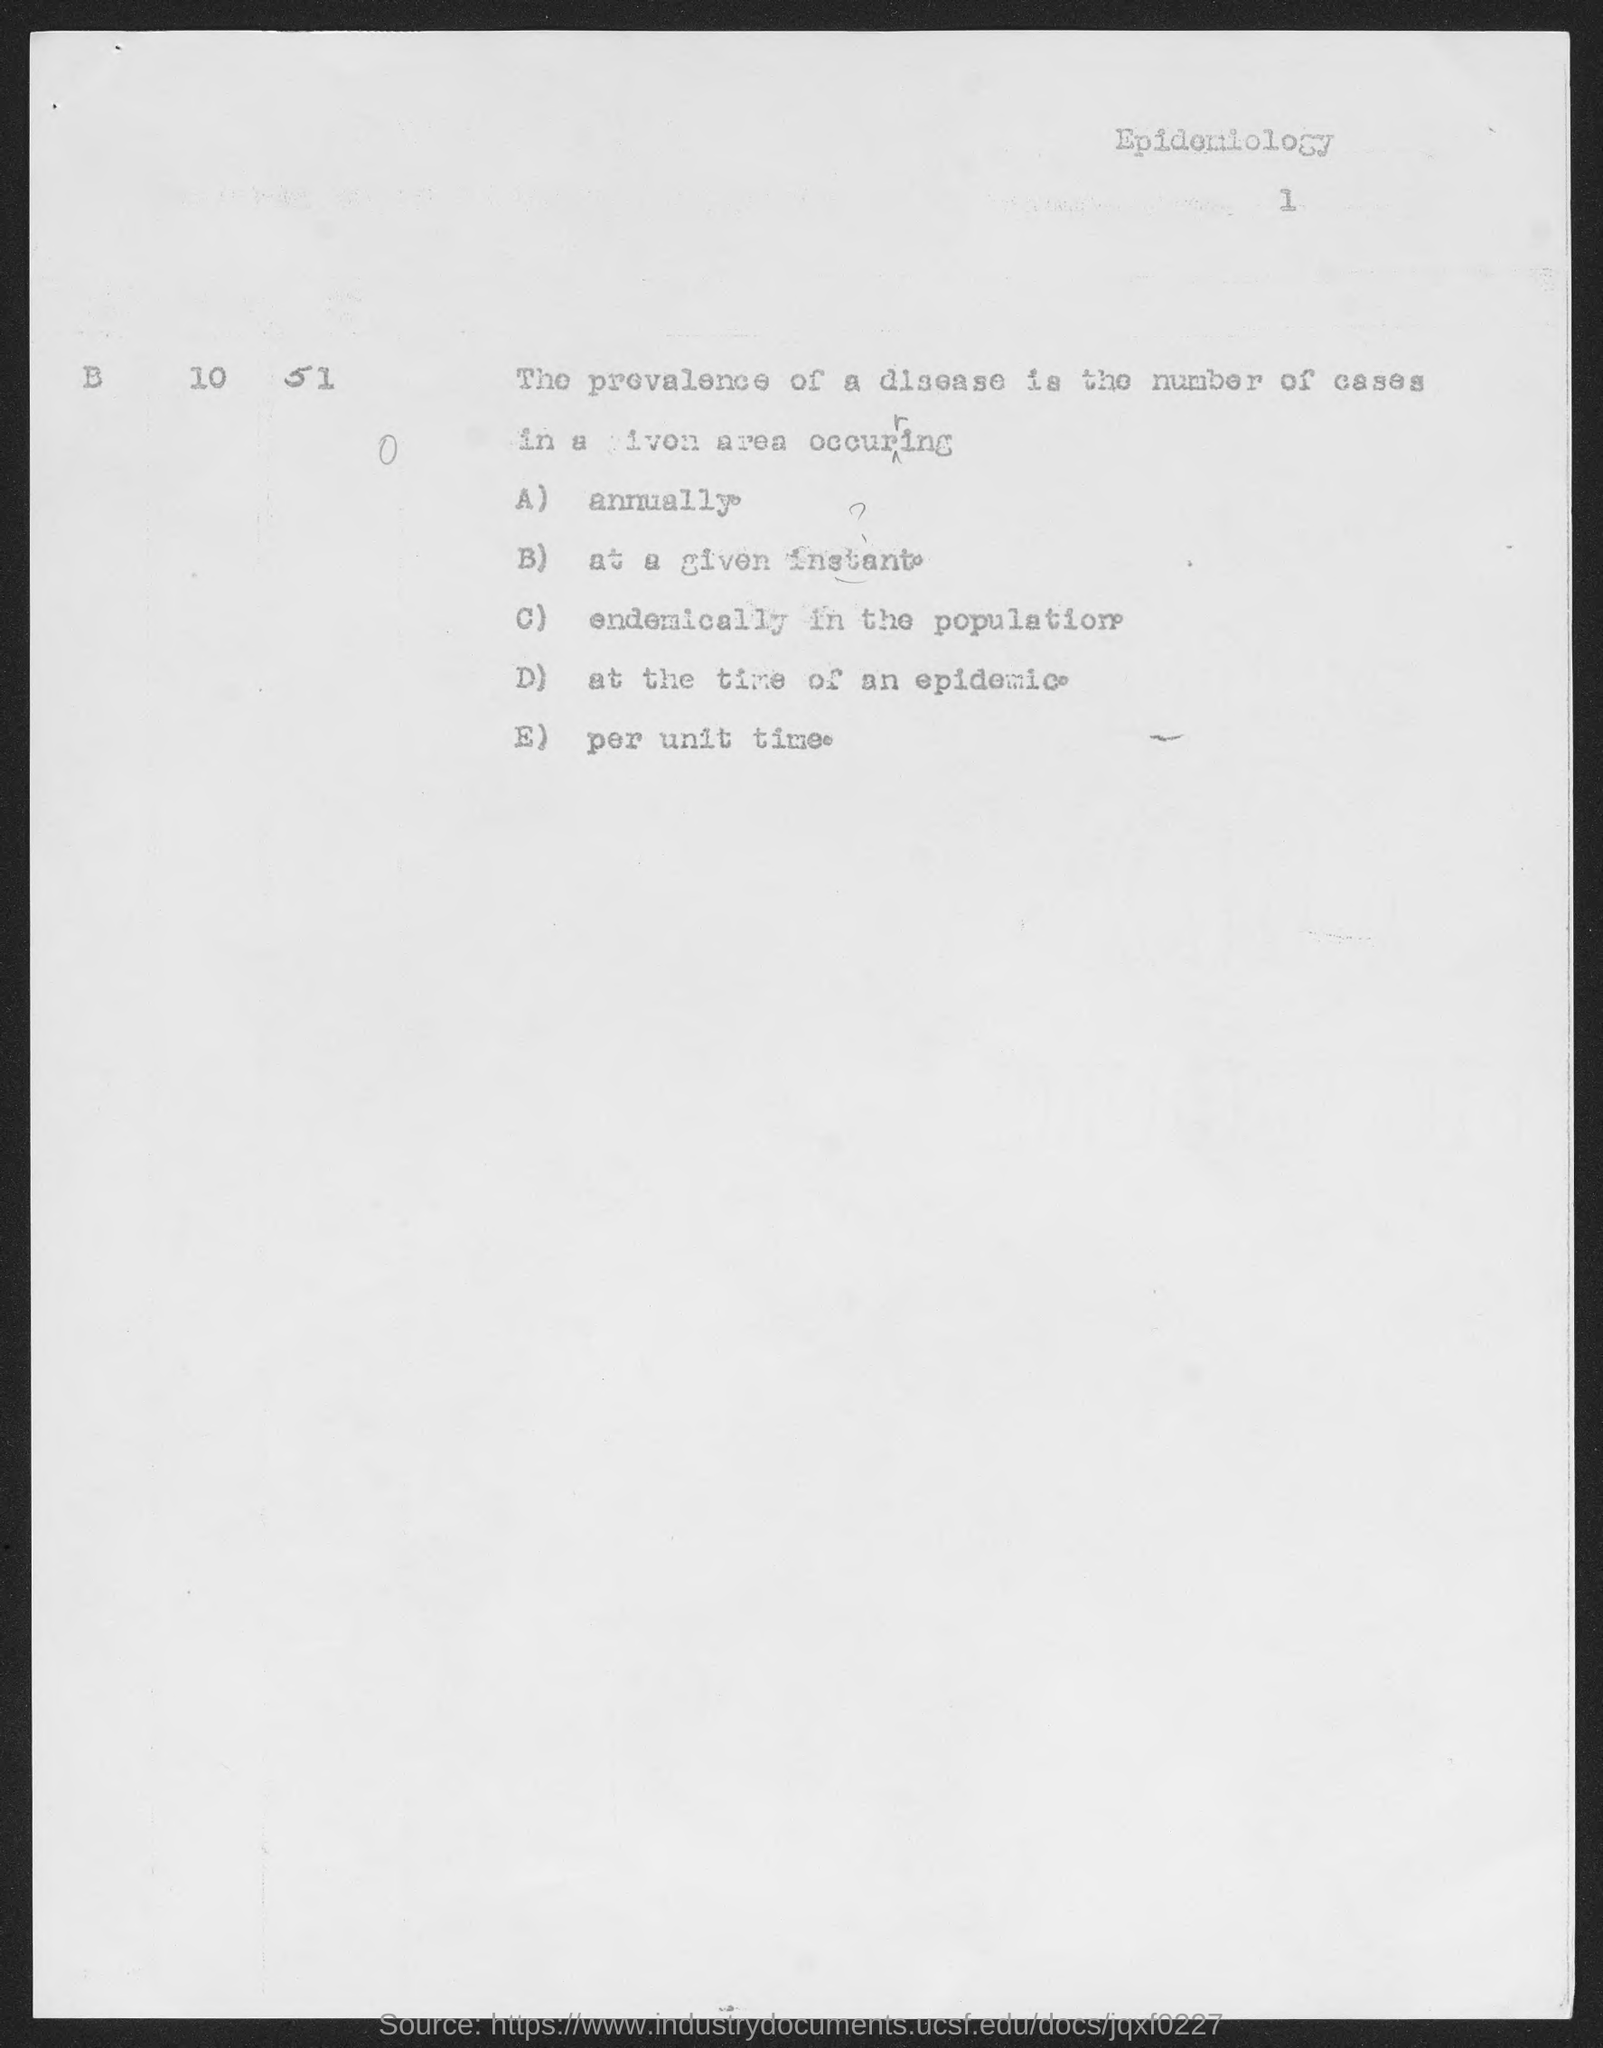Point out several critical features in this image. The option 'A' is an annual one. The subject name mentioned at the top right corner is "Epidemiology. 